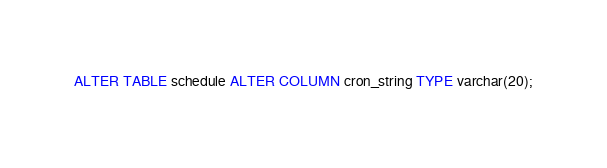<code> <loc_0><loc_0><loc_500><loc_500><_SQL_>ALTER TABLE schedule ALTER COLUMN cron_string TYPE varchar(20);
</code> 